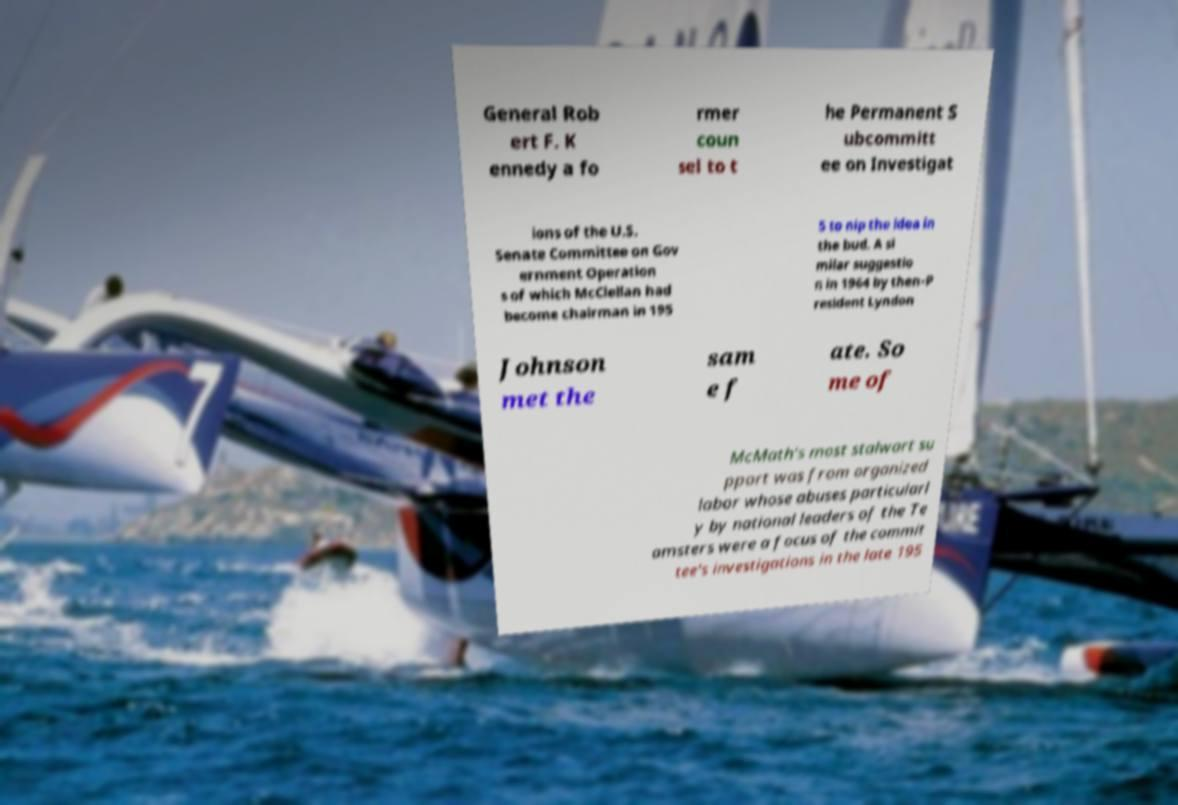There's text embedded in this image that I need extracted. Can you transcribe it verbatim? General Rob ert F. K ennedy a fo rmer coun sel to t he Permanent S ubcommitt ee on Investigat ions of the U.S. Senate Committee on Gov ernment Operation s of which McClellan had become chairman in 195 5 to nip the idea in the bud. A si milar suggestio n in 1964 by then-P resident Lyndon Johnson met the sam e f ate. So me of McMath's most stalwart su pport was from organized labor whose abuses particularl y by national leaders of the Te amsters were a focus of the commit tee's investigations in the late 195 